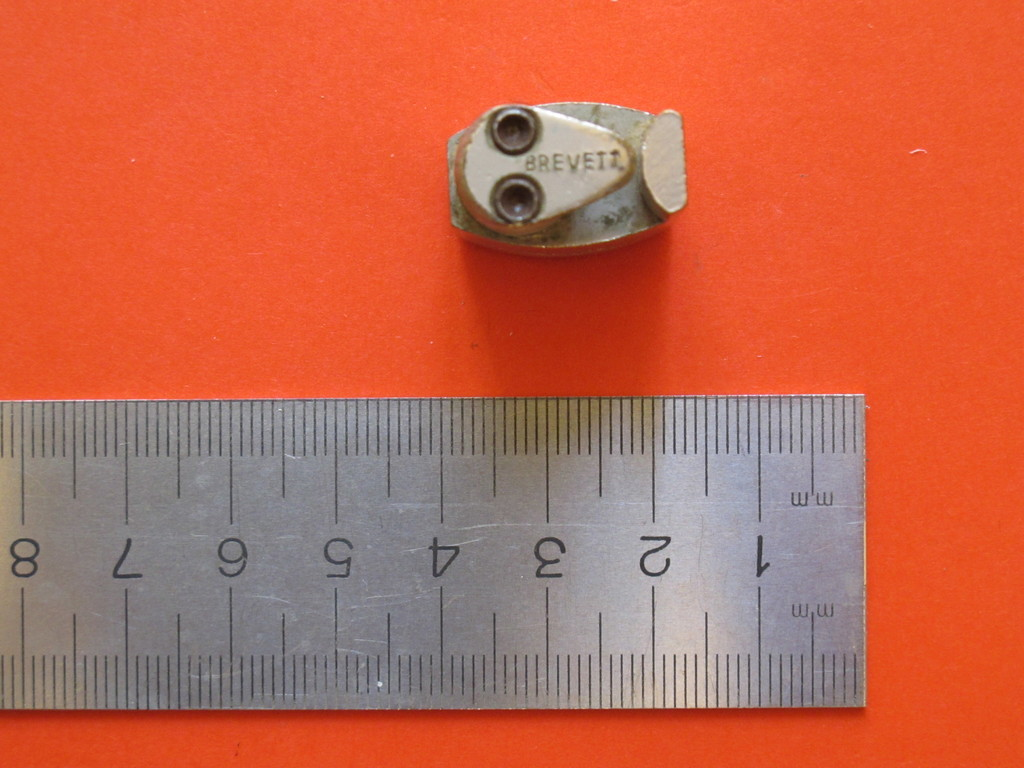Provide a one-sentence caption for the provided image. The image shows a small metal object marked with 'BREVEIZ' alongside a stainless steel ruler on a vivid orange background, potentially used for measuring dimensions or metric comparison. 